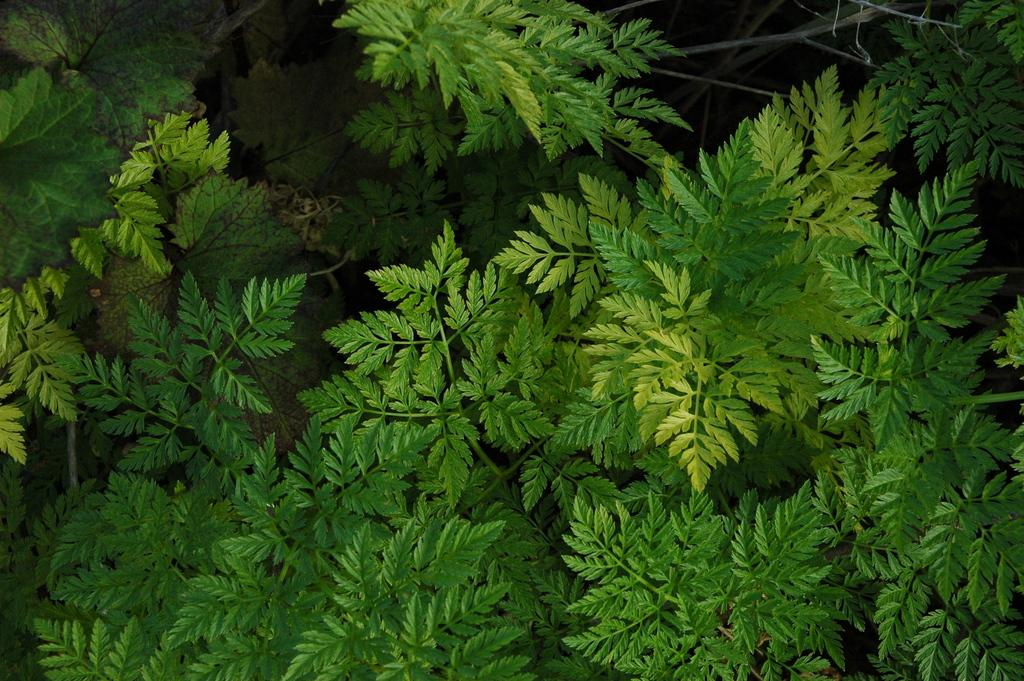What type of plants are visible in the image? There are several green leaf plants in the image. Can you describe the appearance of the plants? The plants have green leaves, but no other specific details are provided. Are there any other objects or elements in the image besides the plants? The provided facts do not mention any other objects or elements in the image. What type of vase is holding the science experiment on the moon in the image? There is no vase, science experiment, or moon present in the image; it only features several green leaf plants. 